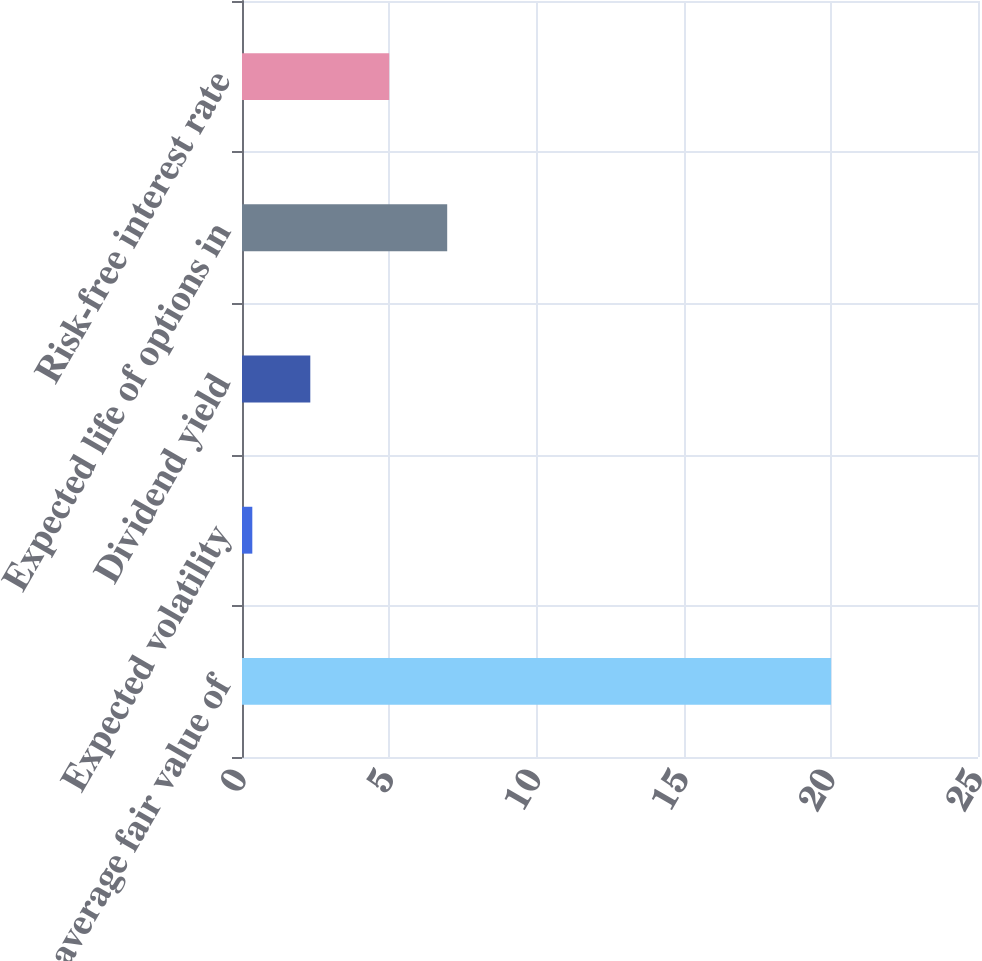<chart> <loc_0><loc_0><loc_500><loc_500><bar_chart><fcel>Weighted average fair value of<fcel>Expected volatility<fcel>Dividend yield<fcel>Expected life of options in<fcel>Risk-free interest rate<nl><fcel>20.01<fcel>0.35<fcel>2.32<fcel>6.97<fcel>5<nl></chart> 